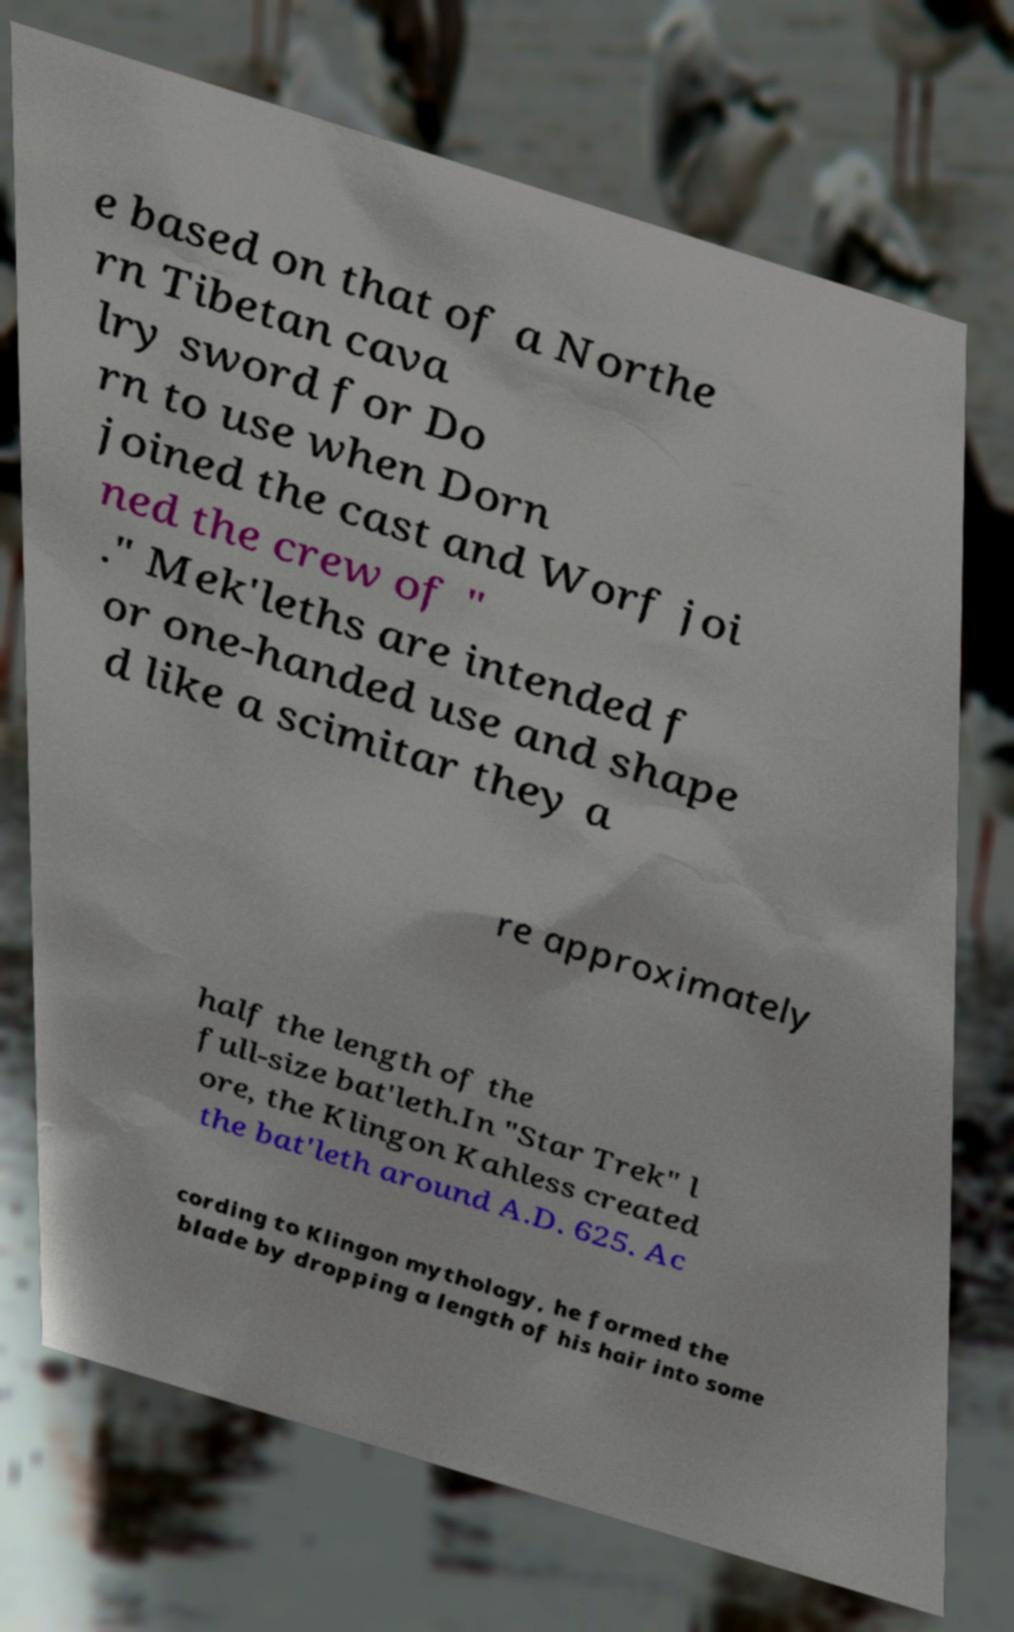What messages or text are displayed in this image? I need them in a readable, typed format. e based on that of a Northe rn Tibetan cava lry sword for Do rn to use when Dorn joined the cast and Worf joi ned the crew of " ." Mek'leths are intended f or one-handed use and shape d like a scimitar they a re approximately half the length of the full-size bat'leth.In "Star Trek" l ore, the Klingon Kahless created the bat'leth around A.D. 625. Ac cording to Klingon mythology, he formed the blade by dropping a length of his hair into some 